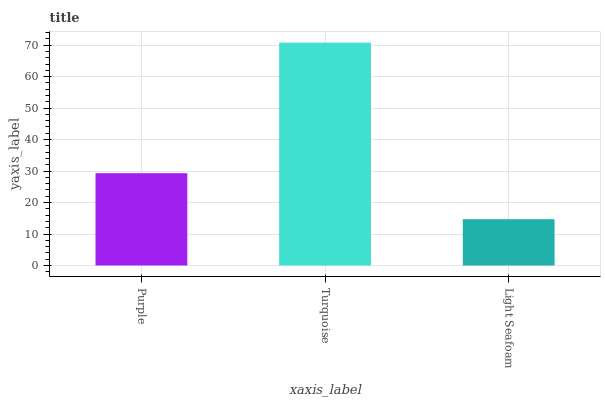Is Light Seafoam the minimum?
Answer yes or no. Yes. Is Turquoise the maximum?
Answer yes or no. Yes. Is Turquoise the minimum?
Answer yes or no. No. Is Light Seafoam the maximum?
Answer yes or no. No. Is Turquoise greater than Light Seafoam?
Answer yes or no. Yes. Is Light Seafoam less than Turquoise?
Answer yes or no. Yes. Is Light Seafoam greater than Turquoise?
Answer yes or no. No. Is Turquoise less than Light Seafoam?
Answer yes or no. No. Is Purple the high median?
Answer yes or no. Yes. Is Purple the low median?
Answer yes or no. Yes. Is Turquoise the high median?
Answer yes or no. No. Is Light Seafoam the low median?
Answer yes or no. No. 